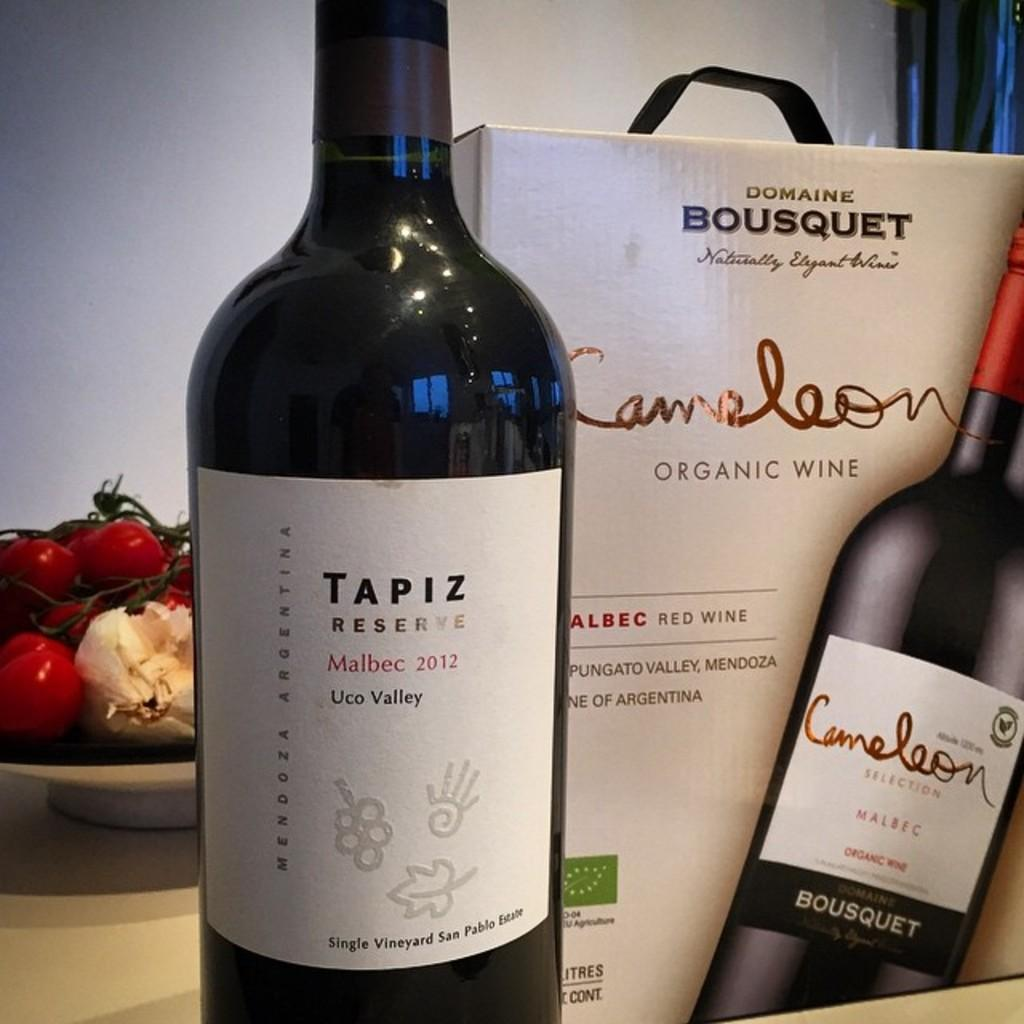Provide a one-sentence caption for the provided image. A black Tapiz Reserve wine bottle and its accompanying box. 